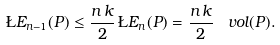Convert formula to latex. <formula><loc_0><loc_0><loc_500><loc_500>\L E _ { n - 1 } ( P ) \leq \frac { n \, k } { 2 } \, \L E _ { n } ( P ) = \frac { n \, k } { 2 } \, \ v o l ( P ) .</formula> 